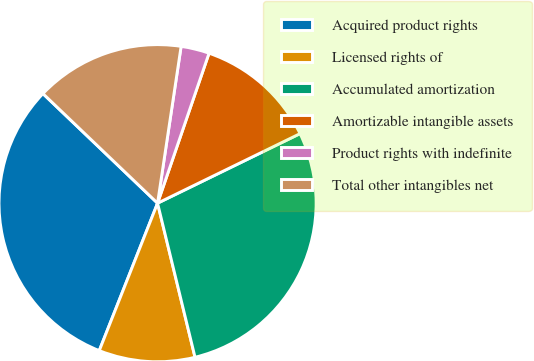Convert chart. <chart><loc_0><loc_0><loc_500><loc_500><pie_chart><fcel>Acquired product rights<fcel>Licensed rights of<fcel>Accumulated amortization<fcel>Amortizable intangible assets<fcel>Product rights with indefinite<fcel>Total other intangibles net<nl><fcel>31.15%<fcel>9.79%<fcel>28.43%<fcel>12.51%<fcel>2.89%<fcel>15.23%<nl></chart> 